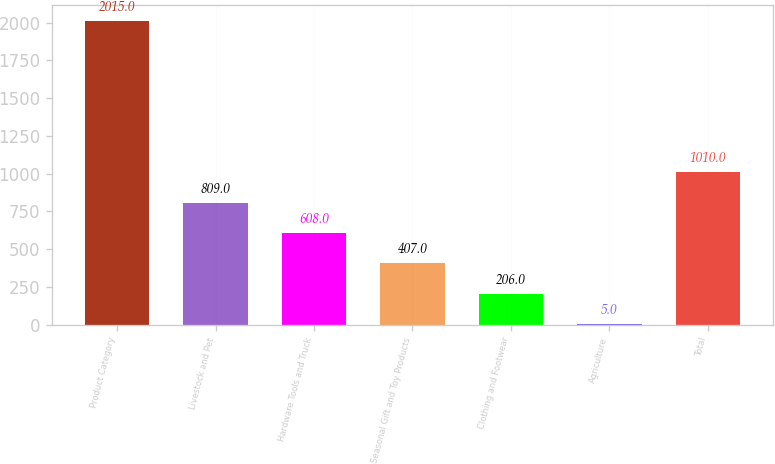<chart> <loc_0><loc_0><loc_500><loc_500><bar_chart><fcel>Product Category<fcel>Livestock and Pet<fcel>Hardware Tools and Truck<fcel>Seasonal Gift and Toy Products<fcel>Clothing and Footwear<fcel>Agriculture<fcel>Total<nl><fcel>2015<fcel>809<fcel>608<fcel>407<fcel>206<fcel>5<fcel>1010<nl></chart> 